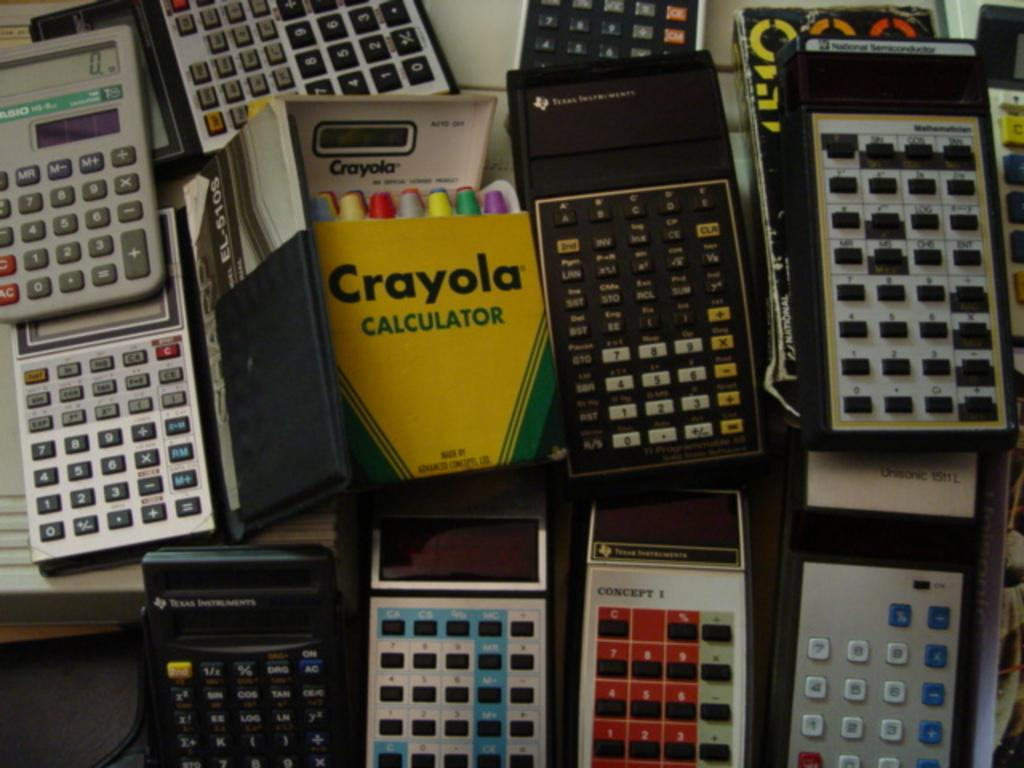<image>
Render a clear and concise summary of the photo. A box of Crayola crayons is in rows of calculators. 